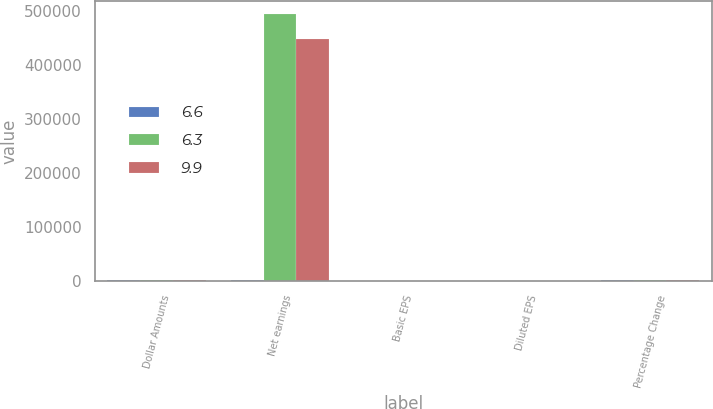Convert chart to OTSL. <chart><loc_0><loc_0><loc_500><loc_500><stacked_bar_chart><ecel><fcel>Dollar Amounts<fcel>Net earnings<fcel>Basic EPS<fcel>Diluted EPS<fcel>Percentage Change<nl><fcel>6.6<fcel>2015<fcel>2013<fcel>1.77<fcel>1.77<fcel>2015<nl><fcel>6.3<fcel>2014<fcel>494150<fcel>1.67<fcel>1.66<fcel>2014<nl><fcel>9.9<fcel>2013<fcel>448636<fcel>1.51<fcel>1.51<fcel>2013<nl></chart> 